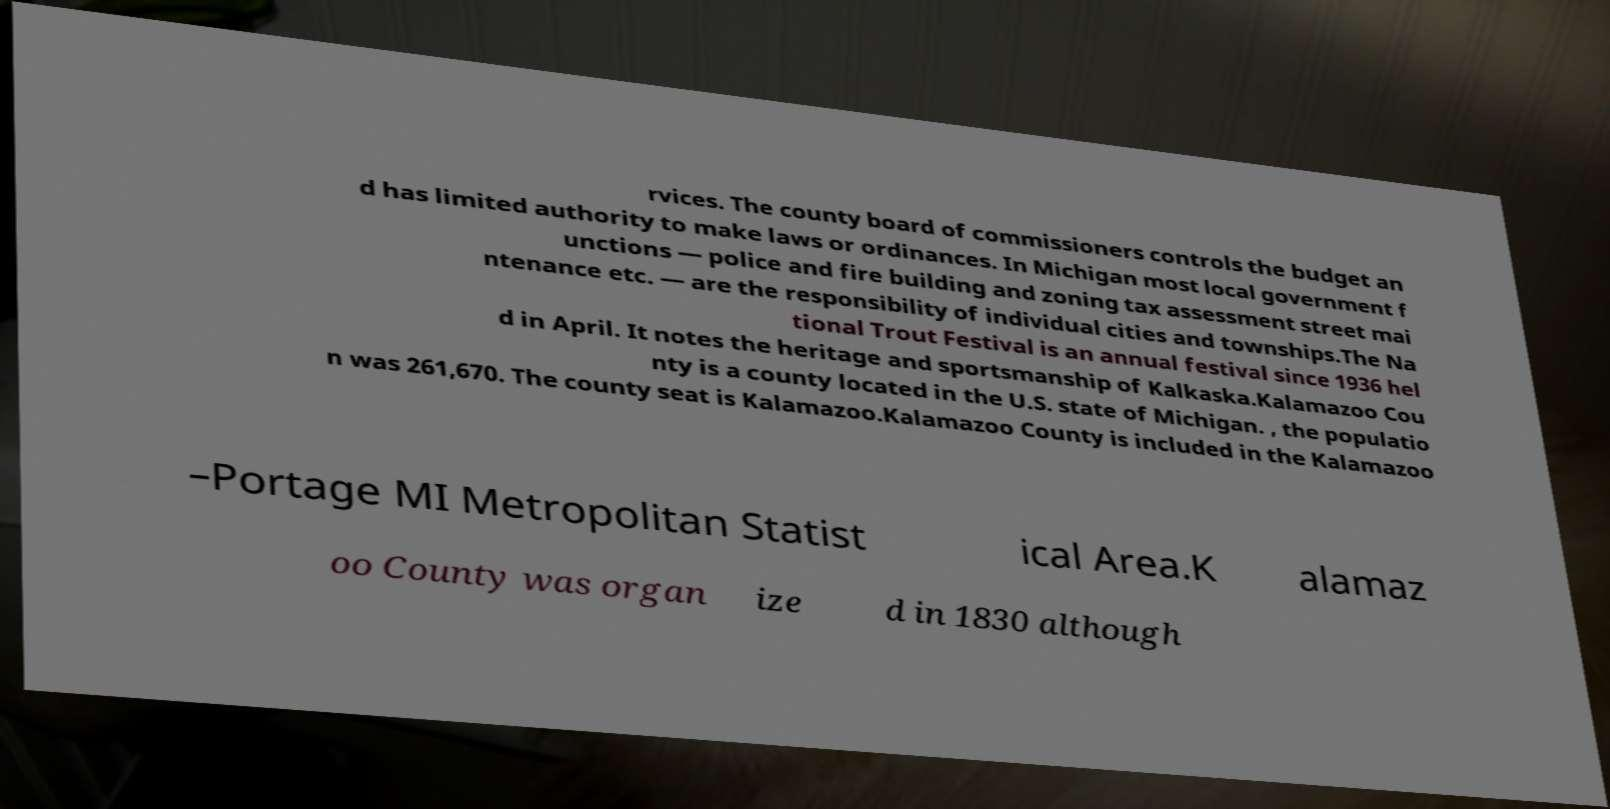Could you extract and type out the text from this image? rvices. The county board of commissioners controls the budget an d has limited authority to make laws or ordinances. In Michigan most local government f unctions — police and fire building and zoning tax assessment street mai ntenance etc. — are the responsibility of individual cities and townships.The Na tional Trout Festival is an annual festival since 1936 hel d in April. It notes the heritage and sportsmanship of Kalkaska.Kalamazoo Cou nty is a county located in the U.S. state of Michigan. , the populatio n was 261,670. The county seat is Kalamazoo.Kalamazoo County is included in the Kalamazoo –Portage MI Metropolitan Statist ical Area.K alamaz oo County was organ ize d in 1830 although 